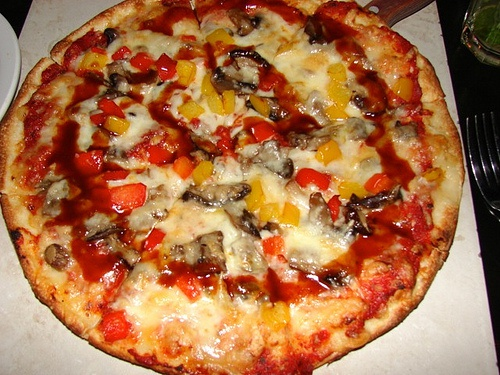Describe the objects in this image and their specific colors. I can see pizza in black, maroon, tan, and brown tones, pizza in black, red, maroon, and tan tones, pizza in black, red, tan, and maroon tones, cup in black, darkgreen, and gray tones, and fork in black, gray, purple, and white tones in this image. 